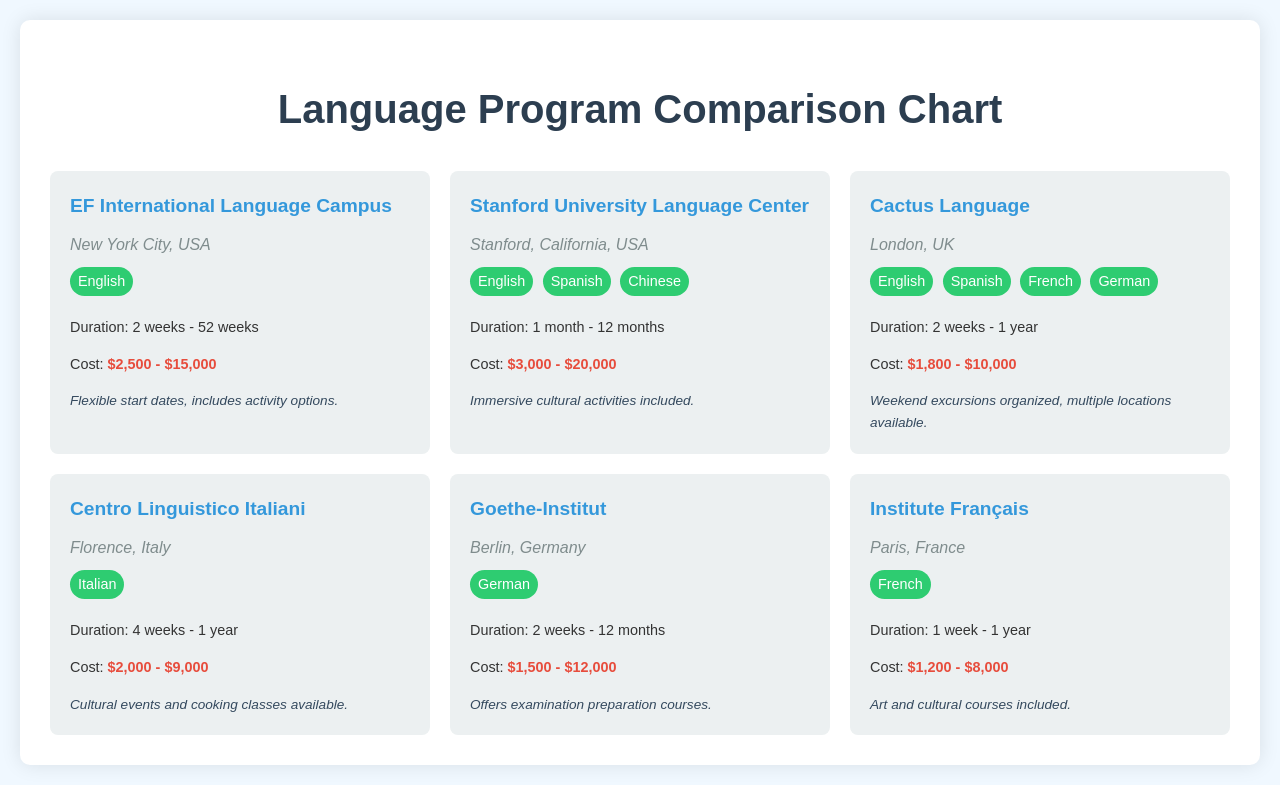What is the cost range for EF International Language Campus? The cost range is provided in the document as $2,500 - $15,000.
Answer: $2,500 - $15,000 Which institution offers a language program in Florence, Italy? The document lists the Centro Linguistico Italiani as the institution in Florence, Italy.
Answer: Centro Linguistico Italiani How many languages does Cactus Language offer? The document mentions that Cactus Language offers four different languages.
Answer: Four What is the duration range for the Stanford University Language Center program? The document indicates that the duration range is from 1 month to 12 months.
Answer: 1 month - 12 months Which city is the Goethe-Institut located in? The document specifies that the Goethe-Institut is in Berlin, Germany.
Answer: Berlin Are there cultural events included in the Centro Linguistico Italiani program? The notes in the document state that cultural events and cooking classes are available as part of the program.
Answer: Yes Which language is offered by the Institute Français? The document clearly states that the Institute Français offers French language courses.
Answer: French What is the highest cost range among the listed programs? By comparing the provided cost ranges in the document, the highest is Stanford University Language Center's $3,000 - $20,000.
Answer: $3,000 - $20,000 